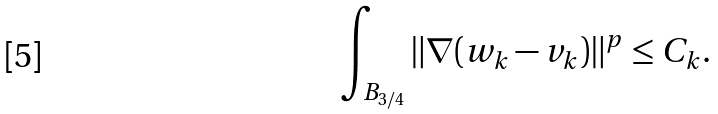Convert formula to latex. <formula><loc_0><loc_0><loc_500><loc_500>\int _ { B _ { 3 / 4 } } \| \nabla ( w _ { k } - v _ { k } ) \| ^ { p } \leq C _ { k } .</formula> 